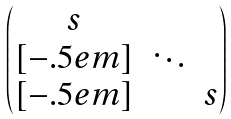Convert formula to latex. <formula><loc_0><loc_0><loc_500><loc_500>\begin{pmatrix} s & & \\ [ - . 5 e m ] & \ddots & \\ [ - . 5 e m ] & & s \end{pmatrix}</formula> 